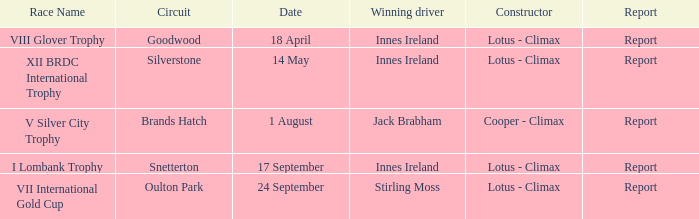What is the name of the race where Stirling Moss was the winning driver? VII International Gold Cup. 